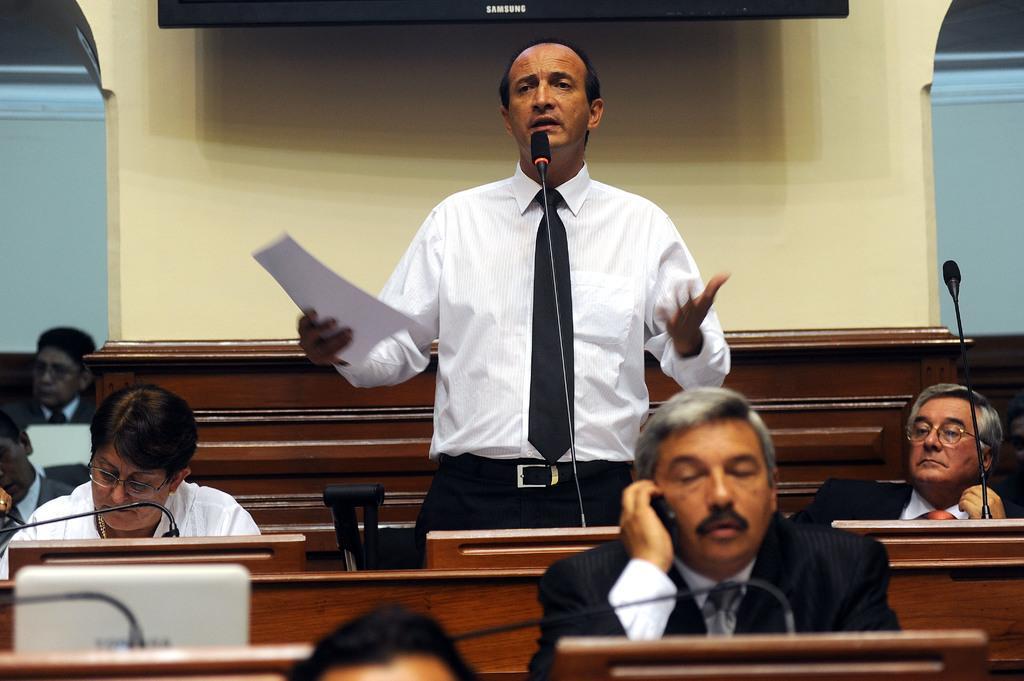How would you summarize this image in a sentence or two? In this image there are people, benches, wall and objects. On the tables there is a laptop and mics. Among them a person is standing and holding a paper. 